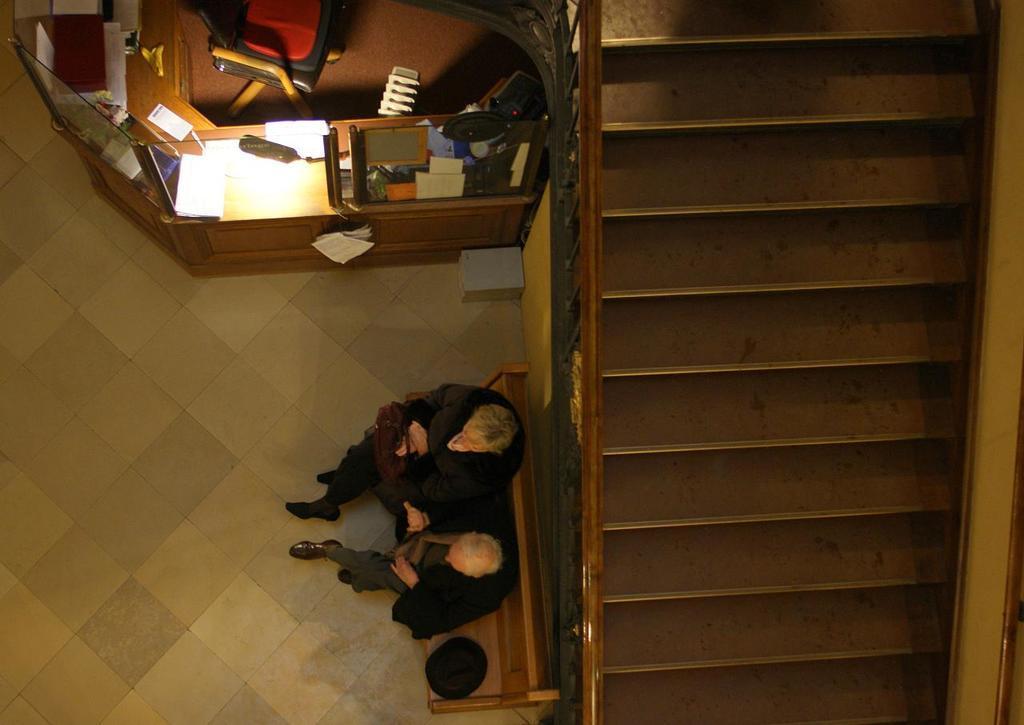In one or two sentences, can you explain what this image depicts? In the center of the image we can see person sitting on the bench. On the right side of the image there are stairs. At the top of the image we can see table and chair. On the table we can see light, books, papers and some boxes. 